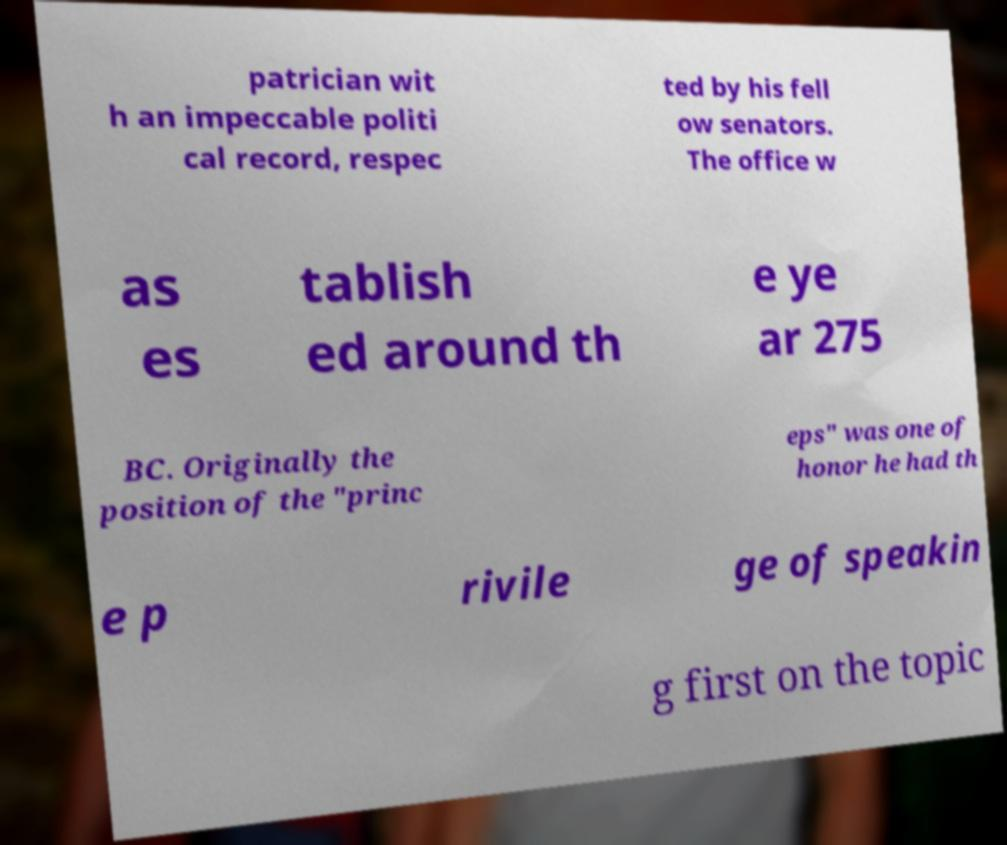Could you extract and type out the text from this image? patrician wit h an impeccable politi cal record, respec ted by his fell ow senators. The office w as es tablish ed around th e ye ar 275 BC. Originally the position of the "princ eps" was one of honor he had th e p rivile ge of speakin g first on the topic 